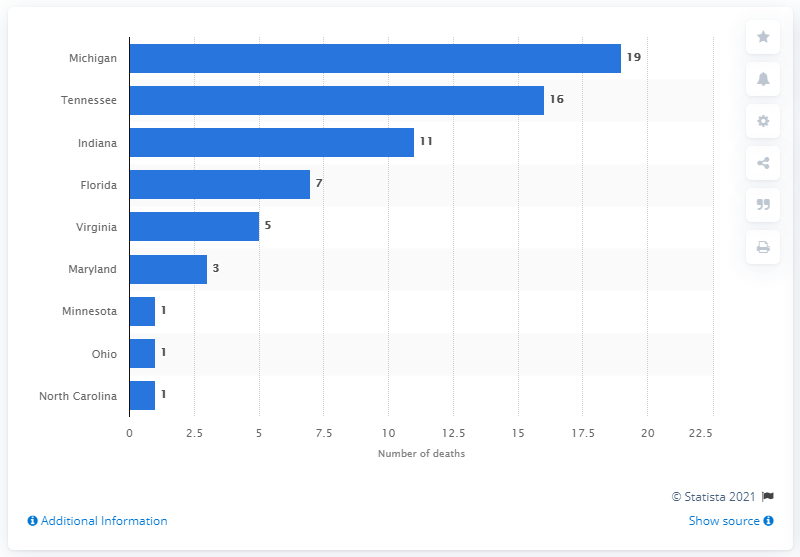Mention a couple of crucial points in this snapshot. According to records, the state of Michigan experienced the highest number of deaths due to fungal infections that were linked to steroid injections. 